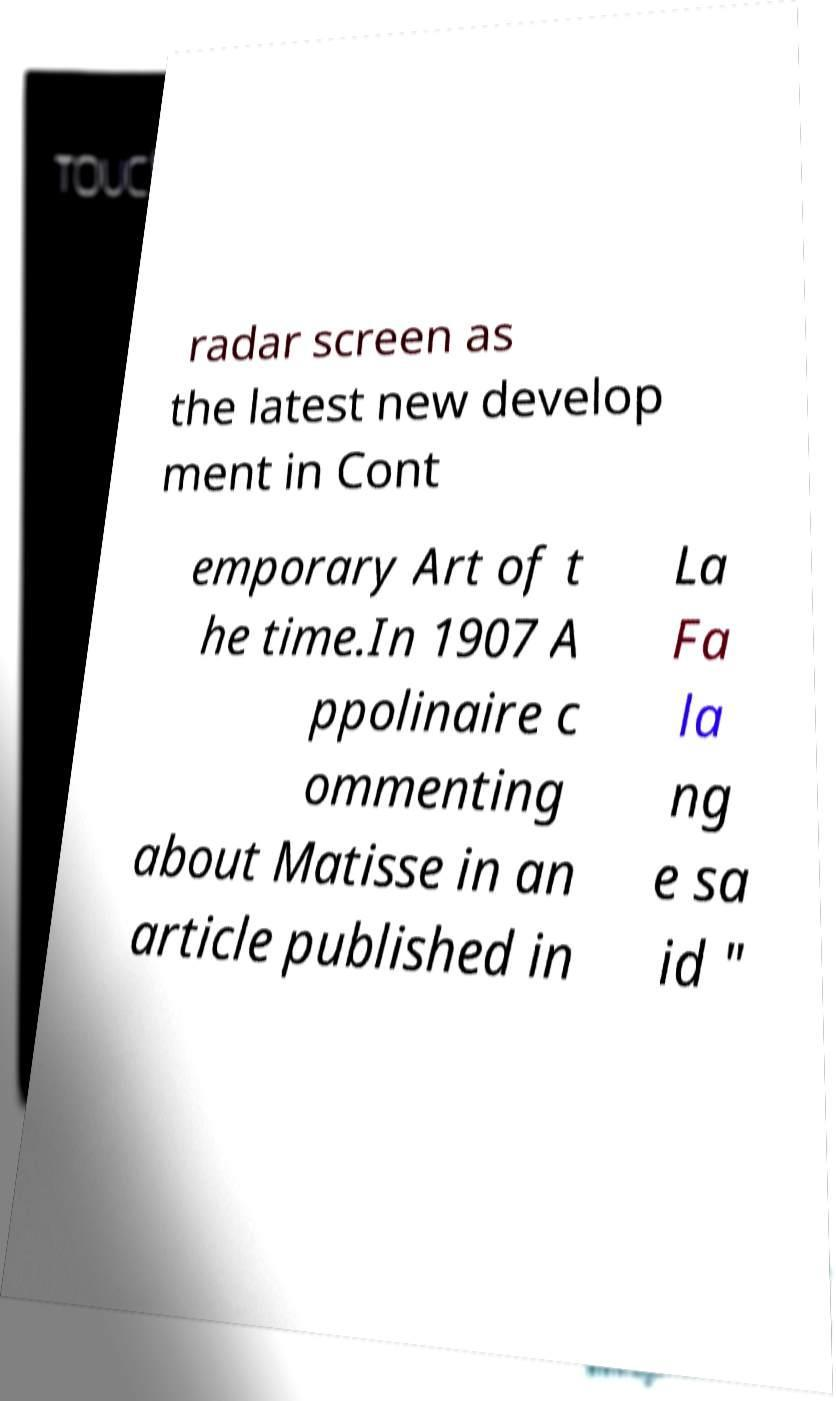Please read and relay the text visible in this image. What does it say? radar screen as the latest new develop ment in Cont emporary Art of t he time.In 1907 A ppolinaire c ommenting about Matisse in an article published in La Fa la ng e sa id " 